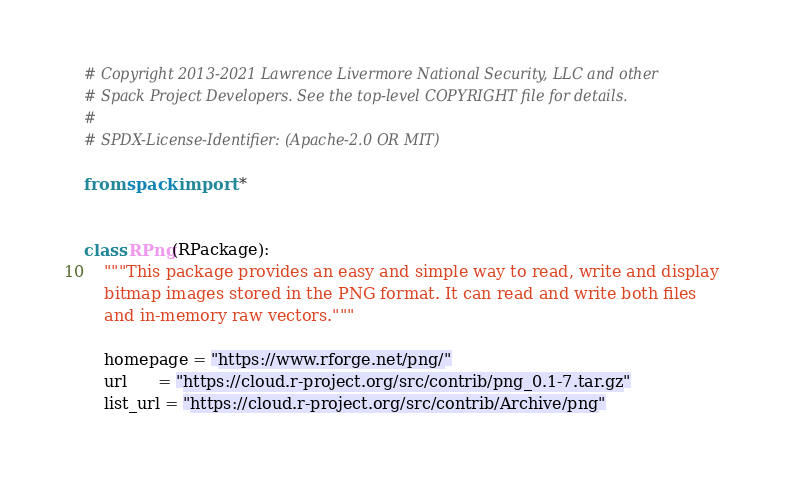<code> <loc_0><loc_0><loc_500><loc_500><_Python_># Copyright 2013-2021 Lawrence Livermore National Security, LLC and other
# Spack Project Developers. See the top-level COPYRIGHT file for details.
#
# SPDX-License-Identifier: (Apache-2.0 OR MIT)

from spack import *


class RPng(RPackage):
    """This package provides an easy and simple way to read, write and display
    bitmap images stored in the PNG format. It can read and write both files
    and in-memory raw vectors."""

    homepage = "https://www.rforge.net/png/"
    url      = "https://cloud.r-project.org/src/contrib/png_0.1-7.tar.gz"
    list_url = "https://cloud.r-project.org/src/contrib/Archive/png"
</code> 